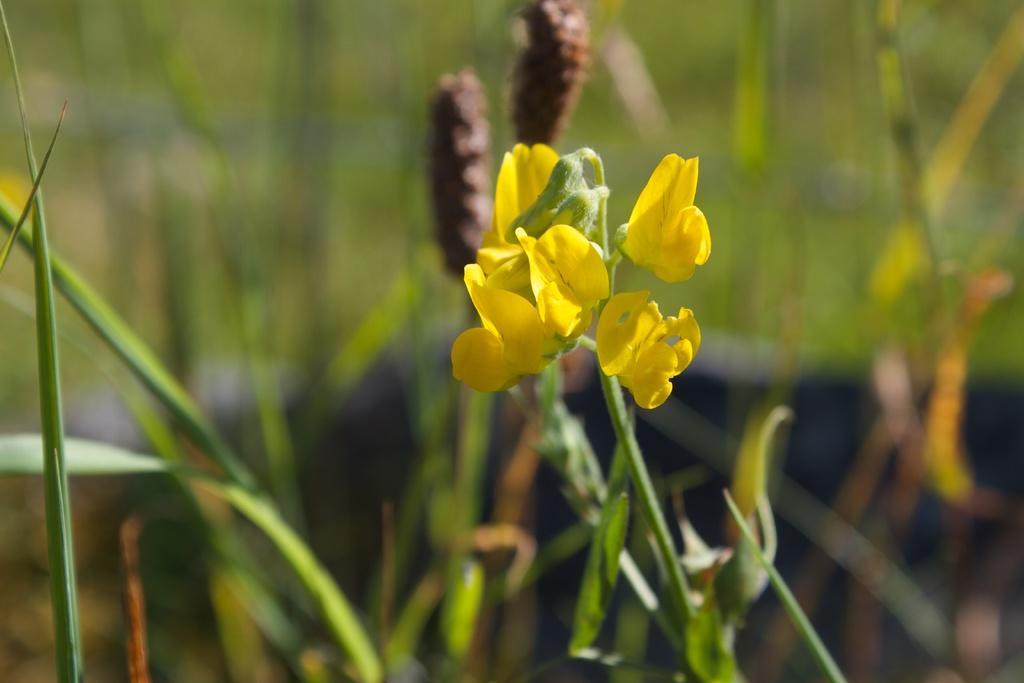In one or two sentences, can you explain what this image depicts? In this image in the middle there are flowers, tents, buds and plants. In the background there is greenery. 